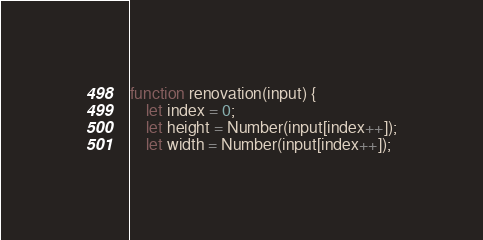Convert code to text. <code><loc_0><loc_0><loc_500><loc_500><_JavaScript_>function renovation(input) {
    let index = 0;
    let height = Number(input[index++]);
    let width = Number(input[index++]);</code> 